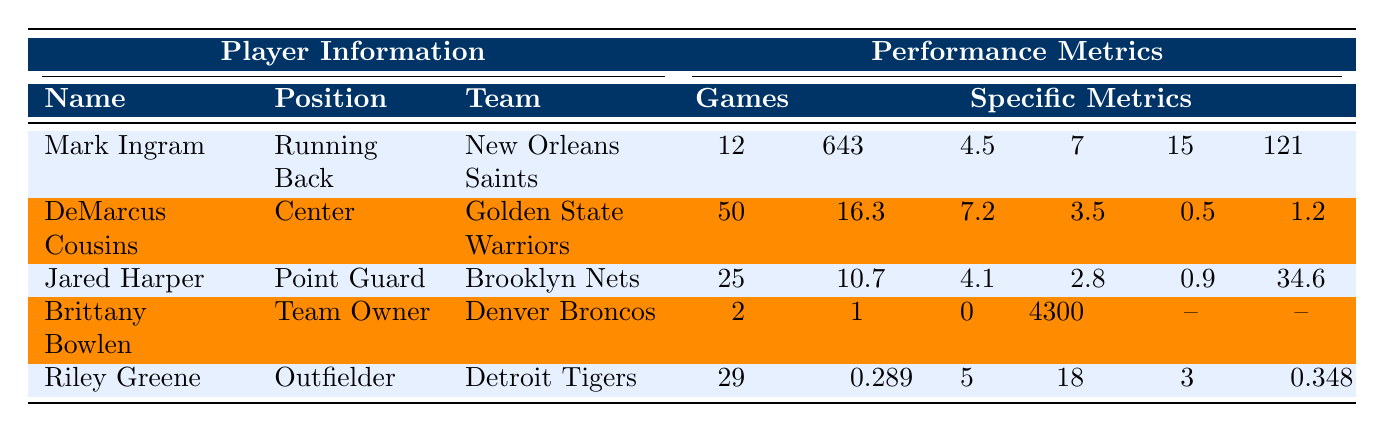What is the team of Mark Ingram? The table lists Mark Ingram in the "Player Information" section, specifically under the "Team" column where it states "New Orleans Saints".
Answer: New Orleans Saints How many games did DeMarcus Cousins play? In the "Performance Metrics" section for DeMarcus Cousins, the value in the "Games" column is 50.
Answer: 50 What is the average yards per carry for Mark Ingram? The "Specific Metrics" for Mark Ingram indicates that he has an average of 4.5 yards per carry.
Answer: 4.5 Which player has the highest number of touchdowns? The "Specific Metrics" for Mark Ingram shows he has 7 touchdowns, while no other player has more than this.
Answer: Mark Ingram Did Brittany Bowlen win a Super Bowl title? The information for Brittany Bowlen indicates "Super_Bowl titles: 0" which means she did not win any title.
Answer: No What is the total number of playoff appearances by Brittany Bowlen? According to the data, Brittany Bowlen has 1 playoff appearance listed in her metrics.
Answer: 1 Which player has the highest batting average? The data shows Riley Greene with a batting average of 0.289, and other players do not have a batting average metric listed, making it the highest.
Answer: Riley Greene Calculate the sum of points per game and assists per game for Jared Harper. Jared Harper's points per game is 10.7 and assists per game is 4.1. Summing these gives 10.7 + 4.1 = 14.8.
Answer: 14.8 Who has the most games played, and what is the number? Comparing the "Games" column, DeMarcus Cousins has played 50 games, which is more than the other players.
Answer: DeMarcus Cousins, 50 What is the ratio of home runs to games played for Riley Greene? Riley Greene has 5 home runs and has played 29 games. The ratio is 5/29, which simplifies to approximately 0.172.
Answer: 0.172 How many players recorded receiving yards in the table? Only Mark Ingram recorded receiving yards (121), while others' metrics don't include them.
Answer: 1 